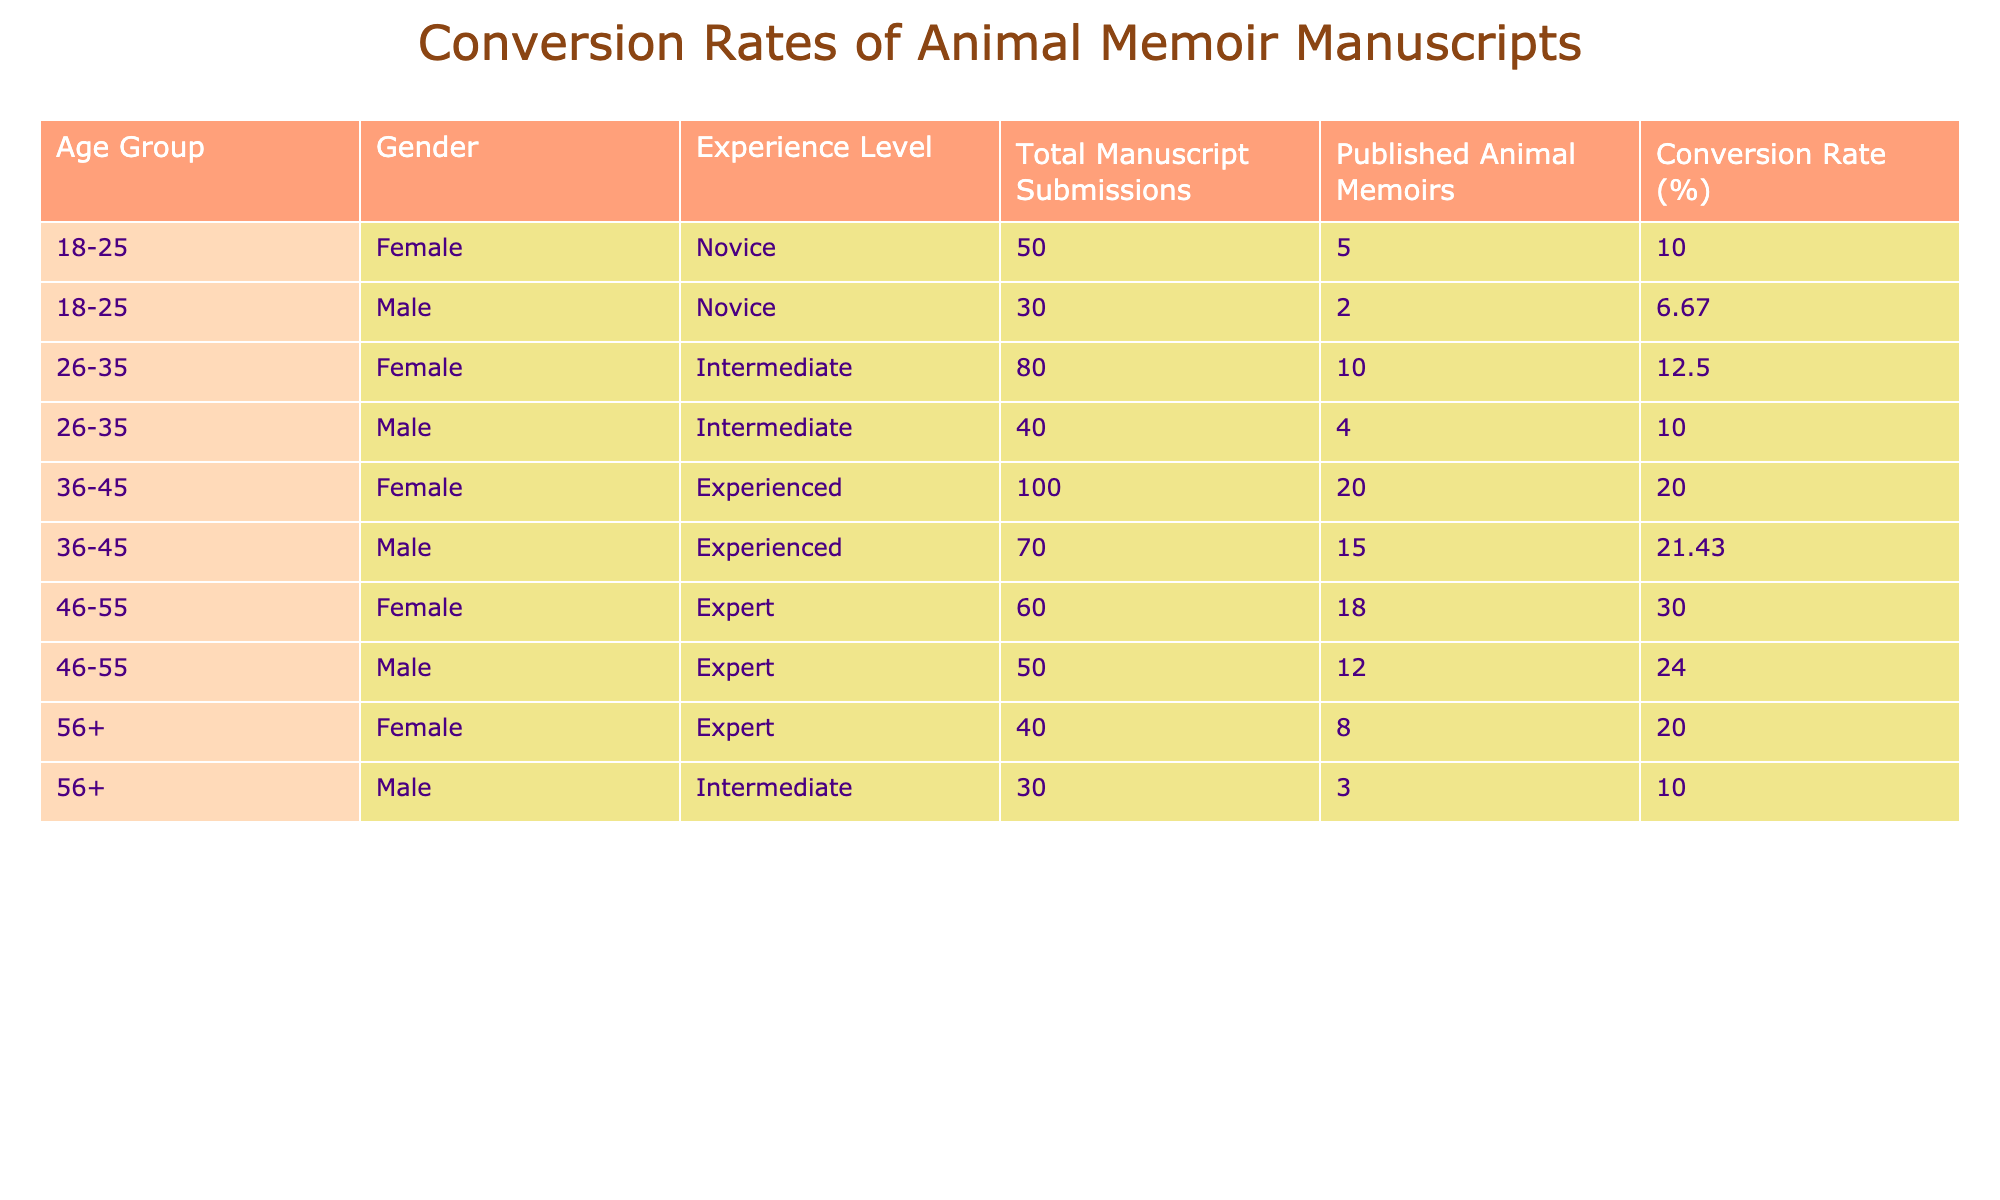What is the highest conversion rate among all age groups? The highest conversion rate is found in the 46-55 age group with 30%. We can identify this by scanning through the 'Conversion Rate (%)' column for the maximum value.
Answer: 30 Which gender has a higher conversion rate at the age of 36-45? Among the age group 36-45, males have a conversion rate of 21.43%, while females have a conversion rate of 20%. Thus, males have the higher conversion rate.
Answer: Male What is the total number of published animal memoirs by authors aged 26-35? To find the total number of published memoirs for authors aged 26-35, we add the values for females (10) and males (4), which gives us a total of 14 published memoirs for this age group.
Answer: 14 Is it true that no novice authors over the age of 45 had their manuscripts published? Yes, it is true. From the data, all novice authors are found in the 18-25 age group, with no novice authors listed in the older age brackets.
Answer: Yes What is the average conversion rate for female authors across all age groups? To calculate the average for female authors, we consider their respective conversion rates: 10%, 12.5%, 20%, 30%, 20%. Adding these gives us 102%, and dividing by 5 (the number of entries) results in an average conversion rate of 20.4%.
Answer: 20.4 Which age group and gender combination has the lowest conversion rate? The lowest conversion rate is from the 18-25 male novice authors with 6.67%. We can find this by comparing all conversion rates in the table.
Answer: 18-25, Male, Novice How many more manuscripts were submitted by experienced female authors than by intermediate female authors? Experienced female authors submitted 100 manuscripts while intermediate female authors submitted 80 manuscripts. The difference is 100 - 80 = 20 more submissions by experienced authors.
Answer: 20 Are there any male authors in the 56+ age group with a higher conversion rate than the male authors in the 36-45 age group? No, the male authors in the 36-45 age group have a higher conversion rate of 21.43% compared to the male authors in the 56+ age group, who have a conversion rate of 10%.
Answer: No 